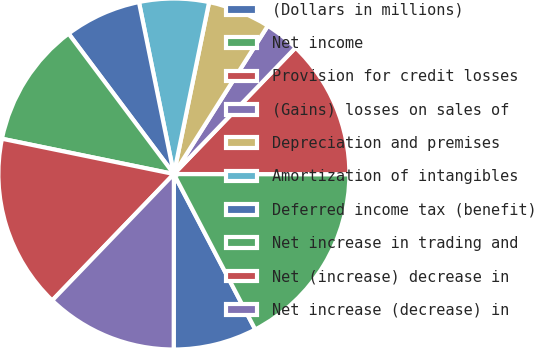<chart> <loc_0><loc_0><loc_500><loc_500><pie_chart><fcel>(Dollars in millions)<fcel>Net income<fcel>Provision for credit losses<fcel>(Gains) losses on sales of<fcel>Depreciation and premises<fcel>Amortization of intangibles<fcel>Deferred income tax (benefit)<fcel>Net increase in trading and<fcel>Net (increase) decrease in<fcel>Net increase (decrease) in<nl><fcel>7.69%<fcel>17.31%<fcel>12.82%<fcel>3.21%<fcel>5.77%<fcel>6.41%<fcel>7.05%<fcel>11.54%<fcel>16.03%<fcel>12.18%<nl></chart> 